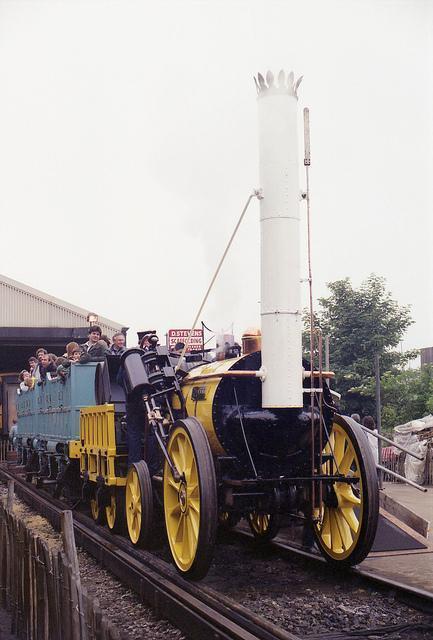How many colors is the train?
Give a very brief answer. 4. How many cats are there?
Give a very brief answer. 0. 